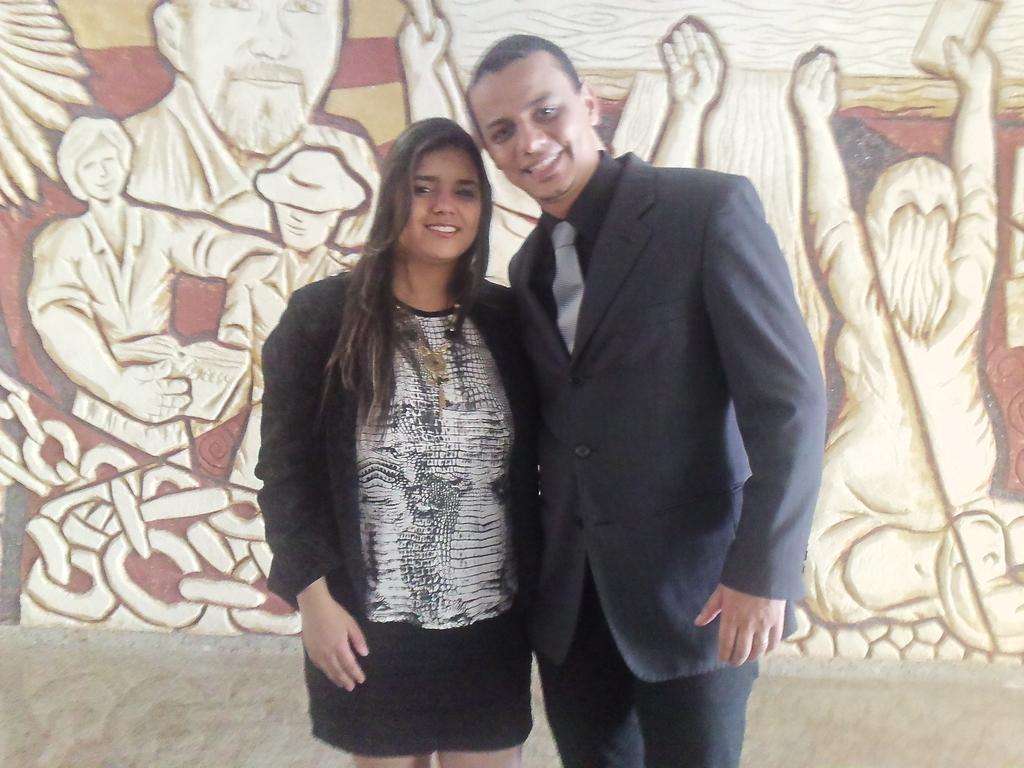How would you summarize this image in a sentence or two? This image consists of two persons a man and a woman. The man is wearing a blue suit. The woman is wearing a black jacket. In the background, we can see an art on the wall. 